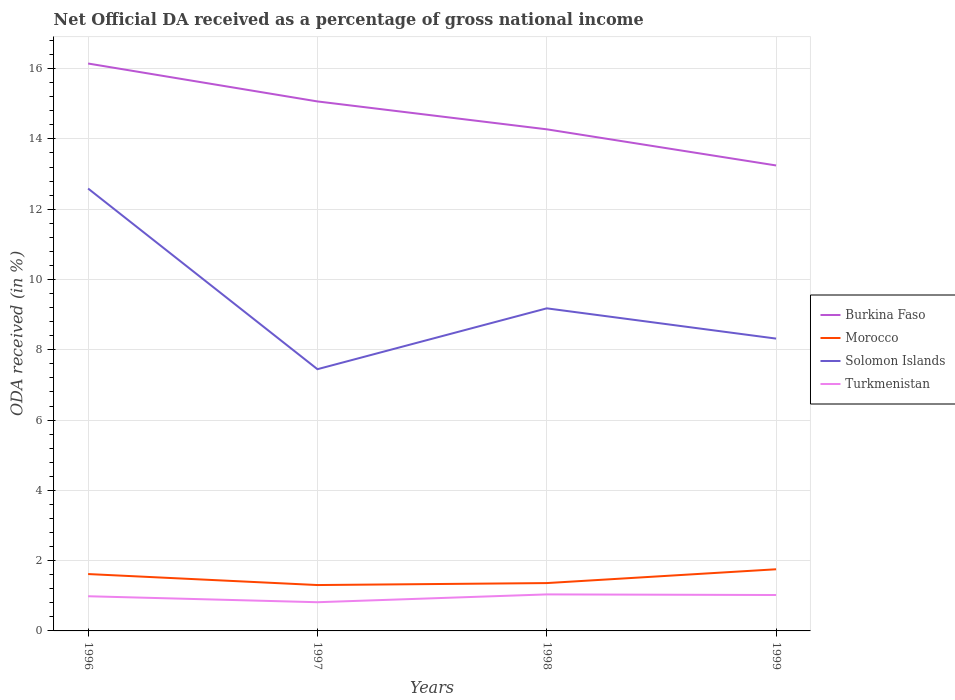How many different coloured lines are there?
Offer a very short reply. 4. Does the line corresponding to Burkina Faso intersect with the line corresponding to Morocco?
Offer a terse response. No. Is the number of lines equal to the number of legend labels?
Ensure brevity in your answer.  Yes. Across all years, what is the maximum net official DA received in Turkmenistan?
Offer a terse response. 0.82. What is the total net official DA received in Morocco in the graph?
Make the answer very short. -0.14. What is the difference between the highest and the second highest net official DA received in Solomon Islands?
Offer a very short reply. 5.14. What is the difference between the highest and the lowest net official DA received in Solomon Islands?
Provide a short and direct response. 1. Is the net official DA received in Solomon Islands strictly greater than the net official DA received in Turkmenistan over the years?
Your answer should be compact. No. Does the graph contain any zero values?
Ensure brevity in your answer.  No. Does the graph contain grids?
Provide a succinct answer. Yes. How many legend labels are there?
Your response must be concise. 4. How are the legend labels stacked?
Provide a short and direct response. Vertical. What is the title of the graph?
Offer a very short reply. Net Official DA received as a percentage of gross national income. Does "St. Lucia" appear as one of the legend labels in the graph?
Make the answer very short. No. What is the label or title of the X-axis?
Your answer should be very brief. Years. What is the label or title of the Y-axis?
Your answer should be compact. ODA received (in %). What is the ODA received (in %) of Burkina Faso in 1996?
Ensure brevity in your answer.  16.15. What is the ODA received (in %) in Morocco in 1996?
Your answer should be compact. 1.62. What is the ODA received (in %) of Solomon Islands in 1996?
Give a very brief answer. 12.59. What is the ODA received (in %) of Turkmenistan in 1996?
Ensure brevity in your answer.  0.99. What is the ODA received (in %) of Burkina Faso in 1997?
Offer a terse response. 15.07. What is the ODA received (in %) of Morocco in 1997?
Offer a very short reply. 1.31. What is the ODA received (in %) of Solomon Islands in 1997?
Offer a terse response. 7.45. What is the ODA received (in %) in Turkmenistan in 1997?
Your response must be concise. 0.82. What is the ODA received (in %) of Burkina Faso in 1998?
Give a very brief answer. 14.27. What is the ODA received (in %) in Morocco in 1998?
Your response must be concise. 1.36. What is the ODA received (in %) in Solomon Islands in 1998?
Your response must be concise. 9.18. What is the ODA received (in %) of Turkmenistan in 1998?
Offer a terse response. 1.04. What is the ODA received (in %) of Burkina Faso in 1999?
Offer a terse response. 13.25. What is the ODA received (in %) of Morocco in 1999?
Your answer should be very brief. 1.75. What is the ODA received (in %) in Solomon Islands in 1999?
Your response must be concise. 8.32. What is the ODA received (in %) in Turkmenistan in 1999?
Provide a succinct answer. 1.02. Across all years, what is the maximum ODA received (in %) in Burkina Faso?
Your response must be concise. 16.15. Across all years, what is the maximum ODA received (in %) of Morocco?
Offer a terse response. 1.75. Across all years, what is the maximum ODA received (in %) in Solomon Islands?
Your answer should be very brief. 12.59. Across all years, what is the maximum ODA received (in %) in Turkmenistan?
Ensure brevity in your answer.  1.04. Across all years, what is the minimum ODA received (in %) of Burkina Faso?
Give a very brief answer. 13.25. Across all years, what is the minimum ODA received (in %) of Morocco?
Give a very brief answer. 1.31. Across all years, what is the minimum ODA received (in %) in Solomon Islands?
Provide a succinct answer. 7.45. Across all years, what is the minimum ODA received (in %) in Turkmenistan?
Provide a short and direct response. 0.82. What is the total ODA received (in %) of Burkina Faso in the graph?
Provide a short and direct response. 58.73. What is the total ODA received (in %) in Morocco in the graph?
Offer a terse response. 6.04. What is the total ODA received (in %) of Solomon Islands in the graph?
Ensure brevity in your answer.  37.53. What is the total ODA received (in %) of Turkmenistan in the graph?
Give a very brief answer. 3.86. What is the difference between the ODA received (in %) in Burkina Faso in 1996 and that in 1997?
Your answer should be compact. 1.08. What is the difference between the ODA received (in %) in Morocco in 1996 and that in 1997?
Your response must be concise. 0.31. What is the difference between the ODA received (in %) of Solomon Islands in 1996 and that in 1997?
Keep it short and to the point. 5.14. What is the difference between the ODA received (in %) in Turkmenistan in 1996 and that in 1997?
Ensure brevity in your answer.  0.17. What is the difference between the ODA received (in %) of Burkina Faso in 1996 and that in 1998?
Provide a succinct answer. 1.87. What is the difference between the ODA received (in %) of Morocco in 1996 and that in 1998?
Your response must be concise. 0.26. What is the difference between the ODA received (in %) in Solomon Islands in 1996 and that in 1998?
Offer a terse response. 3.41. What is the difference between the ODA received (in %) of Turkmenistan in 1996 and that in 1998?
Make the answer very short. -0.05. What is the difference between the ODA received (in %) of Burkina Faso in 1996 and that in 1999?
Keep it short and to the point. 2.9. What is the difference between the ODA received (in %) of Morocco in 1996 and that in 1999?
Offer a terse response. -0.14. What is the difference between the ODA received (in %) of Solomon Islands in 1996 and that in 1999?
Provide a short and direct response. 4.27. What is the difference between the ODA received (in %) of Turkmenistan in 1996 and that in 1999?
Give a very brief answer. -0.04. What is the difference between the ODA received (in %) of Burkina Faso in 1997 and that in 1998?
Provide a short and direct response. 0.79. What is the difference between the ODA received (in %) in Morocco in 1997 and that in 1998?
Your answer should be compact. -0.06. What is the difference between the ODA received (in %) in Solomon Islands in 1997 and that in 1998?
Provide a short and direct response. -1.73. What is the difference between the ODA received (in %) of Turkmenistan in 1997 and that in 1998?
Provide a short and direct response. -0.22. What is the difference between the ODA received (in %) of Burkina Faso in 1997 and that in 1999?
Your answer should be compact. 1.82. What is the difference between the ODA received (in %) of Morocco in 1997 and that in 1999?
Ensure brevity in your answer.  -0.45. What is the difference between the ODA received (in %) in Solomon Islands in 1997 and that in 1999?
Give a very brief answer. -0.87. What is the difference between the ODA received (in %) of Turkmenistan in 1997 and that in 1999?
Your answer should be very brief. -0.21. What is the difference between the ODA received (in %) in Burkina Faso in 1998 and that in 1999?
Ensure brevity in your answer.  1.03. What is the difference between the ODA received (in %) of Morocco in 1998 and that in 1999?
Your answer should be compact. -0.39. What is the difference between the ODA received (in %) of Solomon Islands in 1998 and that in 1999?
Keep it short and to the point. 0.86. What is the difference between the ODA received (in %) of Turkmenistan in 1998 and that in 1999?
Your response must be concise. 0.02. What is the difference between the ODA received (in %) of Burkina Faso in 1996 and the ODA received (in %) of Morocco in 1997?
Provide a succinct answer. 14.84. What is the difference between the ODA received (in %) in Burkina Faso in 1996 and the ODA received (in %) in Solomon Islands in 1997?
Make the answer very short. 8.7. What is the difference between the ODA received (in %) of Burkina Faso in 1996 and the ODA received (in %) of Turkmenistan in 1997?
Your response must be concise. 15.33. What is the difference between the ODA received (in %) of Morocco in 1996 and the ODA received (in %) of Solomon Islands in 1997?
Make the answer very short. -5.83. What is the difference between the ODA received (in %) of Morocco in 1996 and the ODA received (in %) of Turkmenistan in 1997?
Ensure brevity in your answer.  0.8. What is the difference between the ODA received (in %) of Solomon Islands in 1996 and the ODA received (in %) of Turkmenistan in 1997?
Provide a succinct answer. 11.77. What is the difference between the ODA received (in %) of Burkina Faso in 1996 and the ODA received (in %) of Morocco in 1998?
Offer a terse response. 14.78. What is the difference between the ODA received (in %) of Burkina Faso in 1996 and the ODA received (in %) of Solomon Islands in 1998?
Provide a succinct answer. 6.97. What is the difference between the ODA received (in %) in Burkina Faso in 1996 and the ODA received (in %) in Turkmenistan in 1998?
Make the answer very short. 15.11. What is the difference between the ODA received (in %) of Morocco in 1996 and the ODA received (in %) of Solomon Islands in 1998?
Make the answer very short. -7.56. What is the difference between the ODA received (in %) of Morocco in 1996 and the ODA received (in %) of Turkmenistan in 1998?
Give a very brief answer. 0.58. What is the difference between the ODA received (in %) in Solomon Islands in 1996 and the ODA received (in %) in Turkmenistan in 1998?
Provide a short and direct response. 11.55. What is the difference between the ODA received (in %) of Burkina Faso in 1996 and the ODA received (in %) of Morocco in 1999?
Ensure brevity in your answer.  14.39. What is the difference between the ODA received (in %) in Burkina Faso in 1996 and the ODA received (in %) in Solomon Islands in 1999?
Make the answer very short. 7.83. What is the difference between the ODA received (in %) in Burkina Faso in 1996 and the ODA received (in %) in Turkmenistan in 1999?
Give a very brief answer. 15.12. What is the difference between the ODA received (in %) of Morocco in 1996 and the ODA received (in %) of Solomon Islands in 1999?
Offer a very short reply. -6.7. What is the difference between the ODA received (in %) in Morocco in 1996 and the ODA received (in %) in Turkmenistan in 1999?
Your answer should be compact. 0.6. What is the difference between the ODA received (in %) of Solomon Islands in 1996 and the ODA received (in %) of Turkmenistan in 1999?
Make the answer very short. 11.57. What is the difference between the ODA received (in %) in Burkina Faso in 1997 and the ODA received (in %) in Morocco in 1998?
Keep it short and to the point. 13.71. What is the difference between the ODA received (in %) of Burkina Faso in 1997 and the ODA received (in %) of Solomon Islands in 1998?
Offer a terse response. 5.89. What is the difference between the ODA received (in %) in Burkina Faso in 1997 and the ODA received (in %) in Turkmenistan in 1998?
Provide a succinct answer. 14.03. What is the difference between the ODA received (in %) of Morocco in 1997 and the ODA received (in %) of Solomon Islands in 1998?
Your answer should be compact. -7.87. What is the difference between the ODA received (in %) of Morocco in 1997 and the ODA received (in %) of Turkmenistan in 1998?
Your answer should be compact. 0.27. What is the difference between the ODA received (in %) in Solomon Islands in 1997 and the ODA received (in %) in Turkmenistan in 1998?
Provide a short and direct response. 6.41. What is the difference between the ODA received (in %) in Burkina Faso in 1997 and the ODA received (in %) in Morocco in 1999?
Ensure brevity in your answer.  13.31. What is the difference between the ODA received (in %) of Burkina Faso in 1997 and the ODA received (in %) of Solomon Islands in 1999?
Offer a terse response. 6.75. What is the difference between the ODA received (in %) of Burkina Faso in 1997 and the ODA received (in %) of Turkmenistan in 1999?
Provide a short and direct response. 14.05. What is the difference between the ODA received (in %) in Morocco in 1997 and the ODA received (in %) in Solomon Islands in 1999?
Your answer should be very brief. -7.01. What is the difference between the ODA received (in %) of Morocco in 1997 and the ODA received (in %) of Turkmenistan in 1999?
Provide a short and direct response. 0.28. What is the difference between the ODA received (in %) in Solomon Islands in 1997 and the ODA received (in %) in Turkmenistan in 1999?
Your response must be concise. 6.43. What is the difference between the ODA received (in %) in Burkina Faso in 1998 and the ODA received (in %) in Morocco in 1999?
Keep it short and to the point. 12.52. What is the difference between the ODA received (in %) in Burkina Faso in 1998 and the ODA received (in %) in Solomon Islands in 1999?
Provide a succinct answer. 5.96. What is the difference between the ODA received (in %) of Burkina Faso in 1998 and the ODA received (in %) of Turkmenistan in 1999?
Give a very brief answer. 13.25. What is the difference between the ODA received (in %) in Morocco in 1998 and the ODA received (in %) in Solomon Islands in 1999?
Offer a terse response. -6.96. What is the difference between the ODA received (in %) in Morocco in 1998 and the ODA received (in %) in Turkmenistan in 1999?
Ensure brevity in your answer.  0.34. What is the difference between the ODA received (in %) in Solomon Islands in 1998 and the ODA received (in %) in Turkmenistan in 1999?
Your response must be concise. 8.16. What is the average ODA received (in %) in Burkina Faso per year?
Offer a terse response. 14.68. What is the average ODA received (in %) in Morocco per year?
Your answer should be very brief. 1.51. What is the average ODA received (in %) in Solomon Islands per year?
Provide a succinct answer. 9.38. In the year 1996, what is the difference between the ODA received (in %) in Burkina Faso and ODA received (in %) in Morocco?
Your answer should be very brief. 14.53. In the year 1996, what is the difference between the ODA received (in %) in Burkina Faso and ODA received (in %) in Solomon Islands?
Your answer should be very brief. 3.56. In the year 1996, what is the difference between the ODA received (in %) of Burkina Faso and ODA received (in %) of Turkmenistan?
Your answer should be very brief. 15.16. In the year 1996, what is the difference between the ODA received (in %) in Morocco and ODA received (in %) in Solomon Islands?
Your response must be concise. -10.97. In the year 1996, what is the difference between the ODA received (in %) of Morocco and ODA received (in %) of Turkmenistan?
Make the answer very short. 0.63. In the year 1996, what is the difference between the ODA received (in %) of Solomon Islands and ODA received (in %) of Turkmenistan?
Keep it short and to the point. 11.6. In the year 1997, what is the difference between the ODA received (in %) in Burkina Faso and ODA received (in %) in Morocco?
Ensure brevity in your answer.  13.76. In the year 1997, what is the difference between the ODA received (in %) in Burkina Faso and ODA received (in %) in Solomon Islands?
Offer a very short reply. 7.62. In the year 1997, what is the difference between the ODA received (in %) of Burkina Faso and ODA received (in %) of Turkmenistan?
Give a very brief answer. 14.25. In the year 1997, what is the difference between the ODA received (in %) of Morocco and ODA received (in %) of Solomon Islands?
Your response must be concise. -6.14. In the year 1997, what is the difference between the ODA received (in %) in Morocco and ODA received (in %) in Turkmenistan?
Your answer should be compact. 0.49. In the year 1997, what is the difference between the ODA received (in %) in Solomon Islands and ODA received (in %) in Turkmenistan?
Your answer should be compact. 6.63. In the year 1998, what is the difference between the ODA received (in %) of Burkina Faso and ODA received (in %) of Morocco?
Your answer should be compact. 12.91. In the year 1998, what is the difference between the ODA received (in %) in Burkina Faso and ODA received (in %) in Solomon Islands?
Offer a very short reply. 5.09. In the year 1998, what is the difference between the ODA received (in %) in Burkina Faso and ODA received (in %) in Turkmenistan?
Keep it short and to the point. 13.23. In the year 1998, what is the difference between the ODA received (in %) of Morocco and ODA received (in %) of Solomon Islands?
Give a very brief answer. -7.82. In the year 1998, what is the difference between the ODA received (in %) in Morocco and ODA received (in %) in Turkmenistan?
Keep it short and to the point. 0.32. In the year 1998, what is the difference between the ODA received (in %) of Solomon Islands and ODA received (in %) of Turkmenistan?
Keep it short and to the point. 8.14. In the year 1999, what is the difference between the ODA received (in %) in Burkina Faso and ODA received (in %) in Morocco?
Your response must be concise. 11.49. In the year 1999, what is the difference between the ODA received (in %) in Burkina Faso and ODA received (in %) in Solomon Islands?
Offer a very short reply. 4.93. In the year 1999, what is the difference between the ODA received (in %) in Burkina Faso and ODA received (in %) in Turkmenistan?
Ensure brevity in your answer.  12.22. In the year 1999, what is the difference between the ODA received (in %) in Morocco and ODA received (in %) in Solomon Islands?
Your answer should be very brief. -6.56. In the year 1999, what is the difference between the ODA received (in %) in Morocco and ODA received (in %) in Turkmenistan?
Offer a terse response. 0.73. In the year 1999, what is the difference between the ODA received (in %) in Solomon Islands and ODA received (in %) in Turkmenistan?
Make the answer very short. 7.3. What is the ratio of the ODA received (in %) in Burkina Faso in 1996 to that in 1997?
Offer a very short reply. 1.07. What is the ratio of the ODA received (in %) of Morocco in 1996 to that in 1997?
Give a very brief answer. 1.24. What is the ratio of the ODA received (in %) in Solomon Islands in 1996 to that in 1997?
Your response must be concise. 1.69. What is the ratio of the ODA received (in %) of Turkmenistan in 1996 to that in 1997?
Make the answer very short. 1.21. What is the ratio of the ODA received (in %) in Burkina Faso in 1996 to that in 1998?
Your answer should be very brief. 1.13. What is the ratio of the ODA received (in %) of Morocco in 1996 to that in 1998?
Offer a terse response. 1.19. What is the ratio of the ODA received (in %) in Solomon Islands in 1996 to that in 1998?
Ensure brevity in your answer.  1.37. What is the ratio of the ODA received (in %) of Turkmenistan in 1996 to that in 1998?
Your response must be concise. 0.95. What is the ratio of the ODA received (in %) in Burkina Faso in 1996 to that in 1999?
Make the answer very short. 1.22. What is the ratio of the ODA received (in %) of Morocco in 1996 to that in 1999?
Your answer should be compact. 0.92. What is the ratio of the ODA received (in %) of Solomon Islands in 1996 to that in 1999?
Ensure brevity in your answer.  1.51. What is the ratio of the ODA received (in %) of Turkmenistan in 1996 to that in 1999?
Make the answer very short. 0.97. What is the ratio of the ODA received (in %) of Burkina Faso in 1997 to that in 1998?
Your answer should be compact. 1.06. What is the ratio of the ODA received (in %) of Morocco in 1997 to that in 1998?
Your answer should be compact. 0.96. What is the ratio of the ODA received (in %) of Solomon Islands in 1997 to that in 1998?
Make the answer very short. 0.81. What is the ratio of the ODA received (in %) in Turkmenistan in 1997 to that in 1998?
Your answer should be very brief. 0.79. What is the ratio of the ODA received (in %) in Burkina Faso in 1997 to that in 1999?
Offer a terse response. 1.14. What is the ratio of the ODA received (in %) in Morocco in 1997 to that in 1999?
Provide a succinct answer. 0.74. What is the ratio of the ODA received (in %) in Solomon Islands in 1997 to that in 1999?
Your answer should be compact. 0.9. What is the ratio of the ODA received (in %) in Turkmenistan in 1997 to that in 1999?
Make the answer very short. 0.8. What is the ratio of the ODA received (in %) in Burkina Faso in 1998 to that in 1999?
Ensure brevity in your answer.  1.08. What is the ratio of the ODA received (in %) of Morocco in 1998 to that in 1999?
Your answer should be compact. 0.78. What is the ratio of the ODA received (in %) in Solomon Islands in 1998 to that in 1999?
Keep it short and to the point. 1.1. What is the ratio of the ODA received (in %) of Turkmenistan in 1998 to that in 1999?
Make the answer very short. 1.02. What is the difference between the highest and the second highest ODA received (in %) of Burkina Faso?
Your answer should be compact. 1.08. What is the difference between the highest and the second highest ODA received (in %) in Morocco?
Your response must be concise. 0.14. What is the difference between the highest and the second highest ODA received (in %) of Solomon Islands?
Your response must be concise. 3.41. What is the difference between the highest and the second highest ODA received (in %) in Turkmenistan?
Offer a terse response. 0.02. What is the difference between the highest and the lowest ODA received (in %) in Burkina Faso?
Make the answer very short. 2.9. What is the difference between the highest and the lowest ODA received (in %) of Morocco?
Your response must be concise. 0.45. What is the difference between the highest and the lowest ODA received (in %) in Solomon Islands?
Ensure brevity in your answer.  5.14. What is the difference between the highest and the lowest ODA received (in %) of Turkmenistan?
Offer a terse response. 0.22. 